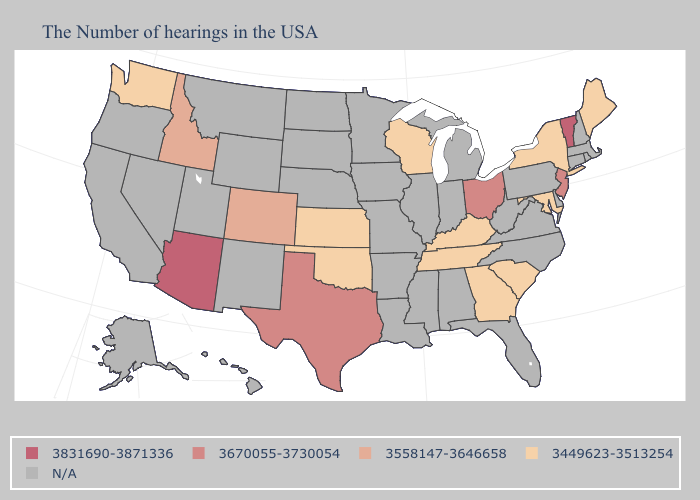Does the map have missing data?
Be succinct. Yes. What is the highest value in the USA?
Quick response, please. 3831690-3871336. What is the lowest value in the South?
Answer briefly. 3449623-3513254. Name the states that have a value in the range N/A?
Concise answer only. Massachusetts, Rhode Island, New Hampshire, Connecticut, Delaware, Pennsylvania, Virginia, North Carolina, West Virginia, Florida, Michigan, Indiana, Alabama, Illinois, Mississippi, Louisiana, Missouri, Arkansas, Minnesota, Iowa, Nebraska, South Dakota, North Dakota, Wyoming, New Mexico, Utah, Montana, Nevada, California, Oregon, Alaska, Hawaii. Name the states that have a value in the range 3831690-3871336?
Give a very brief answer. Vermont, Arizona. Is the legend a continuous bar?
Give a very brief answer. No. What is the highest value in the South ?
Be succinct. 3670055-3730054. Does Washington have the lowest value in the West?
Give a very brief answer. Yes. Does South Carolina have the highest value in the USA?
Give a very brief answer. No. What is the lowest value in the South?
Keep it brief. 3449623-3513254. Which states have the lowest value in the USA?
Keep it brief. Maine, New York, Maryland, South Carolina, Georgia, Kentucky, Tennessee, Wisconsin, Kansas, Oklahoma, Washington. What is the value of Utah?
Give a very brief answer. N/A. What is the value of Maine?
Answer briefly. 3449623-3513254. 